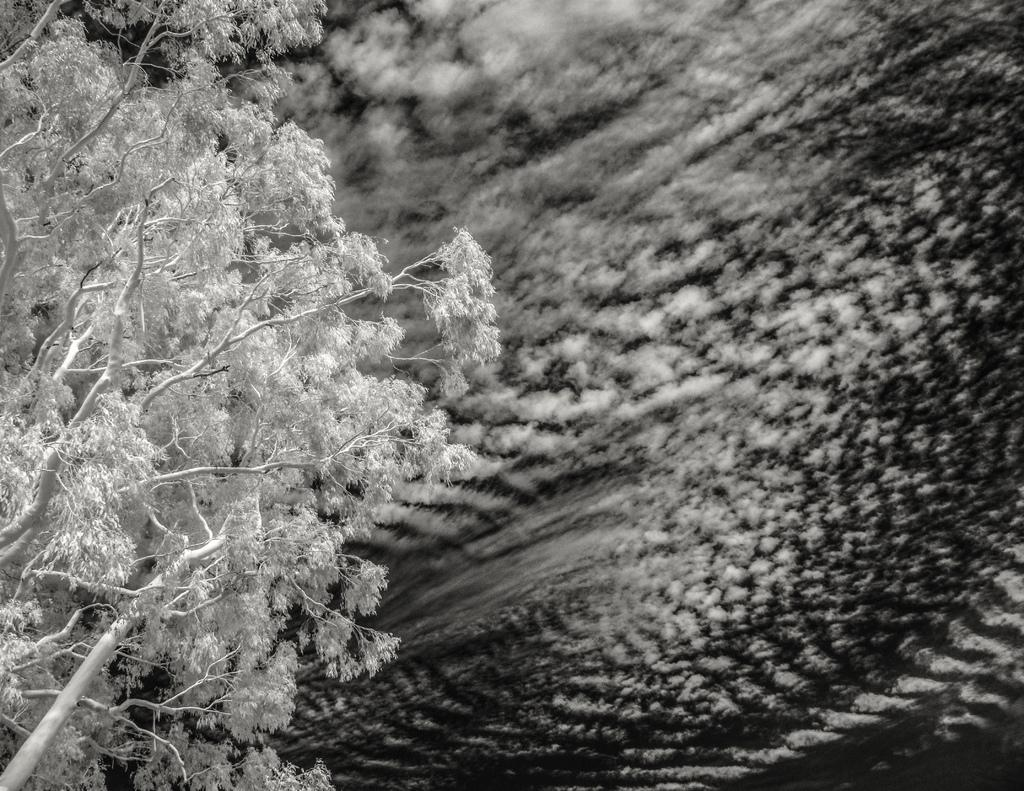What is the color scheme of the image? The image is black and white. What natural element can be seen in the image? There is a tree in the image. Can you describe the background of the image? The background of the image is blurry. What team is responsible for the blurry background in the image? There is no team mentioned or implied in the image, and the blurry background is likely due to the camera settings or distance from the subject. 